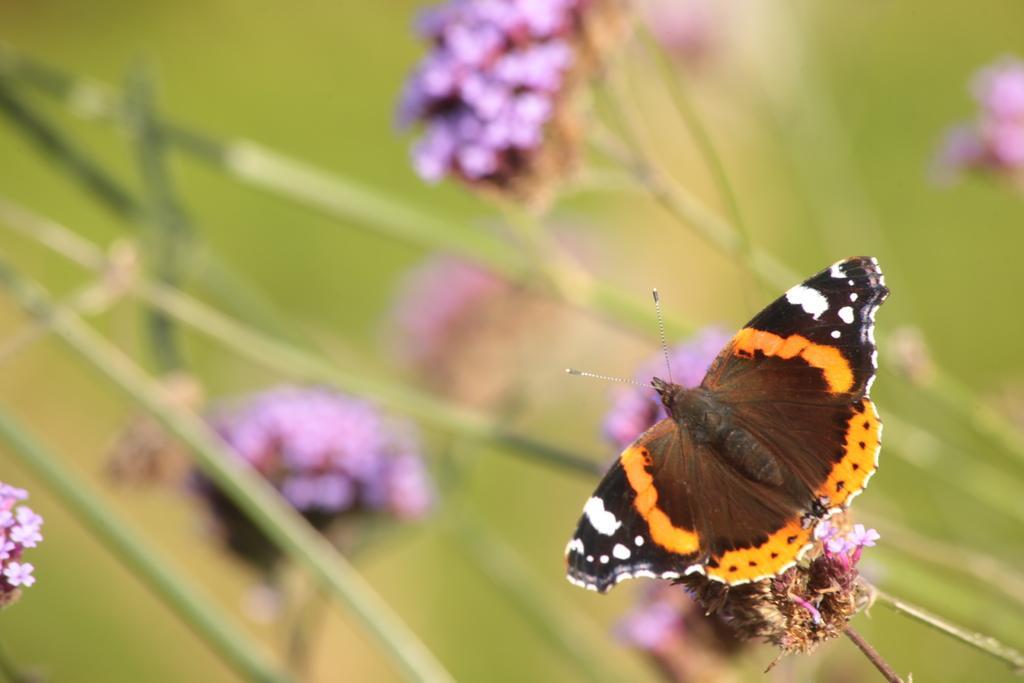How would you summarize this image in a sentence or two? Here we can see a butterfly near this flowers. Background it is blur. We can see flowers and stems. 